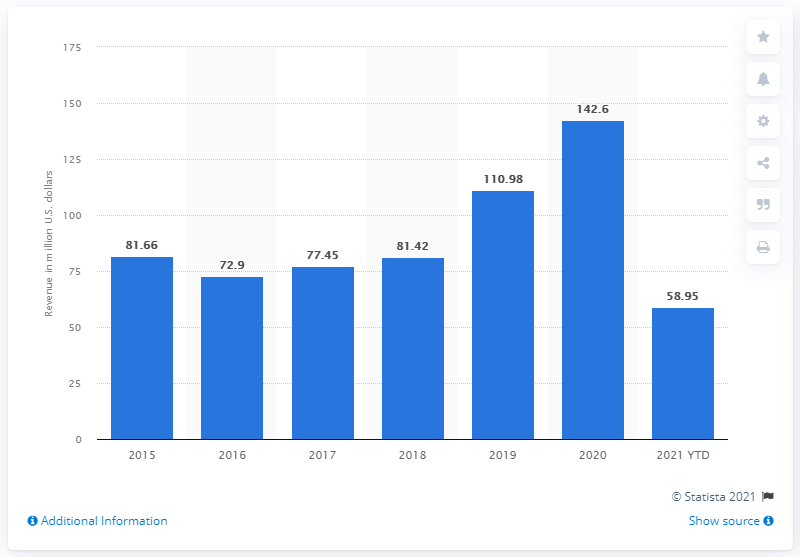Highlight a few significant elements in this photo. In 2020, the global in-app purchases (IAP) revenues for Minecraft were approximately 142.6 million dollars. 